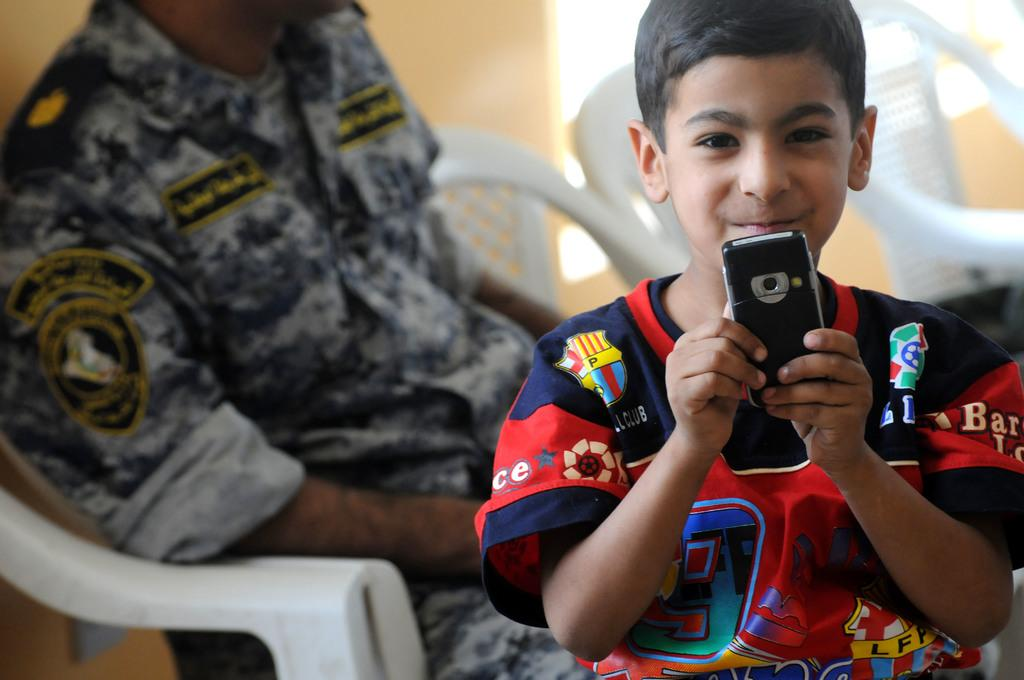What is the main subject of the image? The main subject of the image is a kid. What is the kid doing in the image? The kid is holding a mobile with his hands. Can you describe the person sitting in the image? There is a person sitting on a chair in the image. How many chairs are visible in the image? There are chairs in the image. What is the background of the image? There is a wall in the image. How many eggs are on the umbrella in the image? There is no umbrella or eggs present in the image. What is the distance between the kid and the wall in the image? The distance between the kid and the wall cannot be determined from the image alone, as there is no reference point to measure the distance. 